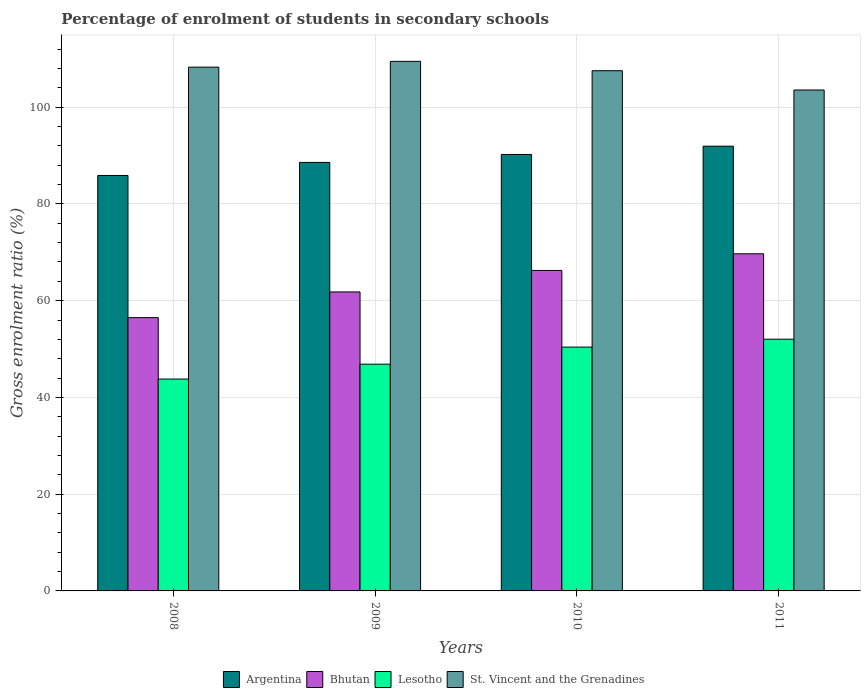How many different coloured bars are there?
Offer a terse response. 4. Are the number of bars on each tick of the X-axis equal?
Offer a very short reply. Yes. In how many cases, is the number of bars for a given year not equal to the number of legend labels?
Make the answer very short. 0. What is the percentage of students enrolled in secondary schools in Lesotho in 2011?
Provide a short and direct response. 52.04. Across all years, what is the maximum percentage of students enrolled in secondary schools in St. Vincent and the Grenadines?
Ensure brevity in your answer.  109.48. Across all years, what is the minimum percentage of students enrolled in secondary schools in Lesotho?
Ensure brevity in your answer.  43.8. What is the total percentage of students enrolled in secondary schools in Lesotho in the graph?
Keep it short and to the point. 193.11. What is the difference between the percentage of students enrolled in secondary schools in Argentina in 2010 and that in 2011?
Offer a terse response. -1.71. What is the difference between the percentage of students enrolled in secondary schools in St. Vincent and the Grenadines in 2011 and the percentage of students enrolled in secondary schools in Argentina in 2008?
Ensure brevity in your answer.  17.67. What is the average percentage of students enrolled in secondary schools in Lesotho per year?
Provide a succinct answer. 48.28. In the year 2009, what is the difference between the percentage of students enrolled in secondary schools in Bhutan and percentage of students enrolled in secondary schools in St. Vincent and the Grenadines?
Provide a short and direct response. -47.67. What is the ratio of the percentage of students enrolled in secondary schools in Bhutan in 2010 to that in 2011?
Offer a terse response. 0.95. Is the percentage of students enrolled in secondary schools in St. Vincent and the Grenadines in 2010 less than that in 2011?
Your answer should be very brief. No. What is the difference between the highest and the second highest percentage of students enrolled in secondary schools in Argentina?
Offer a terse response. 1.71. What is the difference between the highest and the lowest percentage of students enrolled in secondary schools in St. Vincent and the Grenadines?
Provide a succinct answer. 5.92. In how many years, is the percentage of students enrolled in secondary schools in Bhutan greater than the average percentage of students enrolled in secondary schools in Bhutan taken over all years?
Provide a succinct answer. 2. What does the 4th bar from the left in 2009 represents?
Provide a succinct answer. St. Vincent and the Grenadines. What does the 1st bar from the right in 2009 represents?
Provide a short and direct response. St. Vincent and the Grenadines. Are all the bars in the graph horizontal?
Keep it short and to the point. No. How many years are there in the graph?
Your answer should be very brief. 4. What is the difference between two consecutive major ticks on the Y-axis?
Ensure brevity in your answer.  20. Are the values on the major ticks of Y-axis written in scientific E-notation?
Provide a short and direct response. No. What is the title of the graph?
Your answer should be compact. Percentage of enrolment of students in secondary schools. What is the label or title of the X-axis?
Make the answer very short. Years. What is the Gross enrolment ratio (%) in Argentina in 2008?
Your answer should be compact. 85.89. What is the Gross enrolment ratio (%) of Bhutan in 2008?
Make the answer very short. 56.49. What is the Gross enrolment ratio (%) of Lesotho in 2008?
Your response must be concise. 43.8. What is the Gross enrolment ratio (%) of St. Vincent and the Grenadines in 2008?
Offer a very short reply. 108.28. What is the Gross enrolment ratio (%) of Argentina in 2009?
Make the answer very short. 88.58. What is the Gross enrolment ratio (%) of Bhutan in 2009?
Keep it short and to the point. 61.81. What is the Gross enrolment ratio (%) in Lesotho in 2009?
Give a very brief answer. 46.87. What is the Gross enrolment ratio (%) of St. Vincent and the Grenadines in 2009?
Provide a short and direct response. 109.48. What is the Gross enrolment ratio (%) of Argentina in 2010?
Your answer should be very brief. 90.23. What is the Gross enrolment ratio (%) in Bhutan in 2010?
Offer a terse response. 66.25. What is the Gross enrolment ratio (%) in Lesotho in 2010?
Give a very brief answer. 50.4. What is the Gross enrolment ratio (%) in St. Vincent and the Grenadines in 2010?
Offer a terse response. 107.54. What is the Gross enrolment ratio (%) in Argentina in 2011?
Your answer should be very brief. 91.94. What is the Gross enrolment ratio (%) in Bhutan in 2011?
Give a very brief answer. 69.69. What is the Gross enrolment ratio (%) of Lesotho in 2011?
Provide a short and direct response. 52.04. What is the Gross enrolment ratio (%) in St. Vincent and the Grenadines in 2011?
Keep it short and to the point. 103.55. Across all years, what is the maximum Gross enrolment ratio (%) of Argentina?
Provide a short and direct response. 91.94. Across all years, what is the maximum Gross enrolment ratio (%) of Bhutan?
Offer a very short reply. 69.69. Across all years, what is the maximum Gross enrolment ratio (%) in Lesotho?
Your answer should be compact. 52.04. Across all years, what is the maximum Gross enrolment ratio (%) of St. Vincent and the Grenadines?
Provide a short and direct response. 109.48. Across all years, what is the minimum Gross enrolment ratio (%) in Argentina?
Give a very brief answer. 85.89. Across all years, what is the minimum Gross enrolment ratio (%) in Bhutan?
Provide a short and direct response. 56.49. Across all years, what is the minimum Gross enrolment ratio (%) of Lesotho?
Offer a very short reply. 43.8. Across all years, what is the minimum Gross enrolment ratio (%) in St. Vincent and the Grenadines?
Provide a succinct answer. 103.55. What is the total Gross enrolment ratio (%) in Argentina in the graph?
Your response must be concise. 356.63. What is the total Gross enrolment ratio (%) of Bhutan in the graph?
Provide a short and direct response. 254.25. What is the total Gross enrolment ratio (%) of Lesotho in the graph?
Make the answer very short. 193.11. What is the total Gross enrolment ratio (%) of St. Vincent and the Grenadines in the graph?
Offer a very short reply. 428.85. What is the difference between the Gross enrolment ratio (%) of Argentina in 2008 and that in 2009?
Keep it short and to the point. -2.69. What is the difference between the Gross enrolment ratio (%) in Bhutan in 2008 and that in 2009?
Offer a very short reply. -5.31. What is the difference between the Gross enrolment ratio (%) of Lesotho in 2008 and that in 2009?
Make the answer very short. -3.07. What is the difference between the Gross enrolment ratio (%) in St. Vincent and the Grenadines in 2008 and that in 2009?
Provide a short and direct response. -1.2. What is the difference between the Gross enrolment ratio (%) in Argentina in 2008 and that in 2010?
Your answer should be very brief. -4.34. What is the difference between the Gross enrolment ratio (%) in Bhutan in 2008 and that in 2010?
Keep it short and to the point. -9.76. What is the difference between the Gross enrolment ratio (%) in Lesotho in 2008 and that in 2010?
Make the answer very short. -6.61. What is the difference between the Gross enrolment ratio (%) of St. Vincent and the Grenadines in 2008 and that in 2010?
Ensure brevity in your answer.  0.74. What is the difference between the Gross enrolment ratio (%) of Argentina in 2008 and that in 2011?
Make the answer very short. -6.05. What is the difference between the Gross enrolment ratio (%) in Bhutan in 2008 and that in 2011?
Offer a very short reply. -13.2. What is the difference between the Gross enrolment ratio (%) of Lesotho in 2008 and that in 2011?
Give a very brief answer. -8.24. What is the difference between the Gross enrolment ratio (%) of St. Vincent and the Grenadines in 2008 and that in 2011?
Keep it short and to the point. 4.72. What is the difference between the Gross enrolment ratio (%) in Argentina in 2009 and that in 2010?
Give a very brief answer. -1.65. What is the difference between the Gross enrolment ratio (%) in Bhutan in 2009 and that in 2010?
Keep it short and to the point. -4.45. What is the difference between the Gross enrolment ratio (%) in Lesotho in 2009 and that in 2010?
Provide a succinct answer. -3.53. What is the difference between the Gross enrolment ratio (%) in St. Vincent and the Grenadines in 2009 and that in 2010?
Provide a succinct answer. 1.94. What is the difference between the Gross enrolment ratio (%) of Argentina in 2009 and that in 2011?
Your answer should be compact. -3.36. What is the difference between the Gross enrolment ratio (%) in Bhutan in 2009 and that in 2011?
Offer a very short reply. -7.89. What is the difference between the Gross enrolment ratio (%) in Lesotho in 2009 and that in 2011?
Your answer should be compact. -5.16. What is the difference between the Gross enrolment ratio (%) in St. Vincent and the Grenadines in 2009 and that in 2011?
Provide a succinct answer. 5.92. What is the difference between the Gross enrolment ratio (%) in Argentina in 2010 and that in 2011?
Your answer should be compact. -1.71. What is the difference between the Gross enrolment ratio (%) in Bhutan in 2010 and that in 2011?
Provide a succinct answer. -3.44. What is the difference between the Gross enrolment ratio (%) in Lesotho in 2010 and that in 2011?
Your response must be concise. -1.63. What is the difference between the Gross enrolment ratio (%) of St. Vincent and the Grenadines in 2010 and that in 2011?
Offer a terse response. 3.98. What is the difference between the Gross enrolment ratio (%) of Argentina in 2008 and the Gross enrolment ratio (%) of Bhutan in 2009?
Make the answer very short. 24.08. What is the difference between the Gross enrolment ratio (%) in Argentina in 2008 and the Gross enrolment ratio (%) in Lesotho in 2009?
Ensure brevity in your answer.  39.01. What is the difference between the Gross enrolment ratio (%) in Argentina in 2008 and the Gross enrolment ratio (%) in St. Vincent and the Grenadines in 2009?
Ensure brevity in your answer.  -23.59. What is the difference between the Gross enrolment ratio (%) of Bhutan in 2008 and the Gross enrolment ratio (%) of Lesotho in 2009?
Your response must be concise. 9.62. What is the difference between the Gross enrolment ratio (%) of Bhutan in 2008 and the Gross enrolment ratio (%) of St. Vincent and the Grenadines in 2009?
Make the answer very short. -52.98. What is the difference between the Gross enrolment ratio (%) of Lesotho in 2008 and the Gross enrolment ratio (%) of St. Vincent and the Grenadines in 2009?
Provide a short and direct response. -65.68. What is the difference between the Gross enrolment ratio (%) of Argentina in 2008 and the Gross enrolment ratio (%) of Bhutan in 2010?
Your answer should be compact. 19.63. What is the difference between the Gross enrolment ratio (%) in Argentina in 2008 and the Gross enrolment ratio (%) in Lesotho in 2010?
Offer a very short reply. 35.48. What is the difference between the Gross enrolment ratio (%) in Argentina in 2008 and the Gross enrolment ratio (%) in St. Vincent and the Grenadines in 2010?
Offer a very short reply. -21.65. What is the difference between the Gross enrolment ratio (%) in Bhutan in 2008 and the Gross enrolment ratio (%) in Lesotho in 2010?
Make the answer very short. 6.09. What is the difference between the Gross enrolment ratio (%) in Bhutan in 2008 and the Gross enrolment ratio (%) in St. Vincent and the Grenadines in 2010?
Give a very brief answer. -51.04. What is the difference between the Gross enrolment ratio (%) of Lesotho in 2008 and the Gross enrolment ratio (%) of St. Vincent and the Grenadines in 2010?
Your response must be concise. -63.74. What is the difference between the Gross enrolment ratio (%) of Argentina in 2008 and the Gross enrolment ratio (%) of Bhutan in 2011?
Make the answer very short. 16.19. What is the difference between the Gross enrolment ratio (%) in Argentina in 2008 and the Gross enrolment ratio (%) in Lesotho in 2011?
Offer a very short reply. 33.85. What is the difference between the Gross enrolment ratio (%) in Argentina in 2008 and the Gross enrolment ratio (%) in St. Vincent and the Grenadines in 2011?
Offer a terse response. -17.67. What is the difference between the Gross enrolment ratio (%) of Bhutan in 2008 and the Gross enrolment ratio (%) of Lesotho in 2011?
Make the answer very short. 4.46. What is the difference between the Gross enrolment ratio (%) of Bhutan in 2008 and the Gross enrolment ratio (%) of St. Vincent and the Grenadines in 2011?
Make the answer very short. -47.06. What is the difference between the Gross enrolment ratio (%) in Lesotho in 2008 and the Gross enrolment ratio (%) in St. Vincent and the Grenadines in 2011?
Keep it short and to the point. -59.75. What is the difference between the Gross enrolment ratio (%) in Argentina in 2009 and the Gross enrolment ratio (%) in Bhutan in 2010?
Your answer should be compact. 22.33. What is the difference between the Gross enrolment ratio (%) in Argentina in 2009 and the Gross enrolment ratio (%) in Lesotho in 2010?
Your response must be concise. 38.17. What is the difference between the Gross enrolment ratio (%) of Argentina in 2009 and the Gross enrolment ratio (%) of St. Vincent and the Grenadines in 2010?
Your answer should be very brief. -18.96. What is the difference between the Gross enrolment ratio (%) in Bhutan in 2009 and the Gross enrolment ratio (%) in Lesotho in 2010?
Your answer should be very brief. 11.4. What is the difference between the Gross enrolment ratio (%) of Bhutan in 2009 and the Gross enrolment ratio (%) of St. Vincent and the Grenadines in 2010?
Provide a short and direct response. -45.73. What is the difference between the Gross enrolment ratio (%) in Lesotho in 2009 and the Gross enrolment ratio (%) in St. Vincent and the Grenadines in 2010?
Your answer should be very brief. -60.67. What is the difference between the Gross enrolment ratio (%) of Argentina in 2009 and the Gross enrolment ratio (%) of Bhutan in 2011?
Make the answer very short. 18.89. What is the difference between the Gross enrolment ratio (%) of Argentina in 2009 and the Gross enrolment ratio (%) of Lesotho in 2011?
Your answer should be compact. 36.54. What is the difference between the Gross enrolment ratio (%) of Argentina in 2009 and the Gross enrolment ratio (%) of St. Vincent and the Grenadines in 2011?
Give a very brief answer. -14.97. What is the difference between the Gross enrolment ratio (%) of Bhutan in 2009 and the Gross enrolment ratio (%) of Lesotho in 2011?
Offer a terse response. 9.77. What is the difference between the Gross enrolment ratio (%) in Bhutan in 2009 and the Gross enrolment ratio (%) in St. Vincent and the Grenadines in 2011?
Offer a terse response. -41.75. What is the difference between the Gross enrolment ratio (%) in Lesotho in 2009 and the Gross enrolment ratio (%) in St. Vincent and the Grenadines in 2011?
Provide a short and direct response. -56.68. What is the difference between the Gross enrolment ratio (%) of Argentina in 2010 and the Gross enrolment ratio (%) of Bhutan in 2011?
Make the answer very short. 20.53. What is the difference between the Gross enrolment ratio (%) in Argentina in 2010 and the Gross enrolment ratio (%) in Lesotho in 2011?
Offer a terse response. 38.19. What is the difference between the Gross enrolment ratio (%) in Argentina in 2010 and the Gross enrolment ratio (%) in St. Vincent and the Grenadines in 2011?
Provide a short and direct response. -13.33. What is the difference between the Gross enrolment ratio (%) in Bhutan in 2010 and the Gross enrolment ratio (%) in Lesotho in 2011?
Make the answer very short. 14.22. What is the difference between the Gross enrolment ratio (%) of Bhutan in 2010 and the Gross enrolment ratio (%) of St. Vincent and the Grenadines in 2011?
Make the answer very short. -37.3. What is the difference between the Gross enrolment ratio (%) of Lesotho in 2010 and the Gross enrolment ratio (%) of St. Vincent and the Grenadines in 2011?
Your answer should be very brief. -53.15. What is the average Gross enrolment ratio (%) of Argentina per year?
Keep it short and to the point. 89.16. What is the average Gross enrolment ratio (%) in Bhutan per year?
Offer a very short reply. 63.56. What is the average Gross enrolment ratio (%) in Lesotho per year?
Your answer should be compact. 48.28. What is the average Gross enrolment ratio (%) in St. Vincent and the Grenadines per year?
Your response must be concise. 107.21. In the year 2008, what is the difference between the Gross enrolment ratio (%) in Argentina and Gross enrolment ratio (%) in Bhutan?
Ensure brevity in your answer.  29.39. In the year 2008, what is the difference between the Gross enrolment ratio (%) in Argentina and Gross enrolment ratio (%) in Lesotho?
Ensure brevity in your answer.  42.09. In the year 2008, what is the difference between the Gross enrolment ratio (%) in Argentina and Gross enrolment ratio (%) in St. Vincent and the Grenadines?
Provide a short and direct response. -22.39. In the year 2008, what is the difference between the Gross enrolment ratio (%) in Bhutan and Gross enrolment ratio (%) in Lesotho?
Give a very brief answer. 12.7. In the year 2008, what is the difference between the Gross enrolment ratio (%) of Bhutan and Gross enrolment ratio (%) of St. Vincent and the Grenadines?
Your answer should be very brief. -51.78. In the year 2008, what is the difference between the Gross enrolment ratio (%) of Lesotho and Gross enrolment ratio (%) of St. Vincent and the Grenadines?
Your answer should be very brief. -64.48. In the year 2009, what is the difference between the Gross enrolment ratio (%) of Argentina and Gross enrolment ratio (%) of Bhutan?
Ensure brevity in your answer.  26.77. In the year 2009, what is the difference between the Gross enrolment ratio (%) of Argentina and Gross enrolment ratio (%) of Lesotho?
Provide a succinct answer. 41.71. In the year 2009, what is the difference between the Gross enrolment ratio (%) of Argentina and Gross enrolment ratio (%) of St. Vincent and the Grenadines?
Ensure brevity in your answer.  -20.9. In the year 2009, what is the difference between the Gross enrolment ratio (%) of Bhutan and Gross enrolment ratio (%) of Lesotho?
Make the answer very short. 14.93. In the year 2009, what is the difference between the Gross enrolment ratio (%) in Bhutan and Gross enrolment ratio (%) in St. Vincent and the Grenadines?
Offer a terse response. -47.67. In the year 2009, what is the difference between the Gross enrolment ratio (%) of Lesotho and Gross enrolment ratio (%) of St. Vincent and the Grenadines?
Offer a very short reply. -62.6. In the year 2010, what is the difference between the Gross enrolment ratio (%) of Argentina and Gross enrolment ratio (%) of Bhutan?
Your response must be concise. 23.97. In the year 2010, what is the difference between the Gross enrolment ratio (%) in Argentina and Gross enrolment ratio (%) in Lesotho?
Your answer should be compact. 39.82. In the year 2010, what is the difference between the Gross enrolment ratio (%) in Argentina and Gross enrolment ratio (%) in St. Vincent and the Grenadines?
Offer a very short reply. -17.31. In the year 2010, what is the difference between the Gross enrolment ratio (%) of Bhutan and Gross enrolment ratio (%) of Lesotho?
Keep it short and to the point. 15.85. In the year 2010, what is the difference between the Gross enrolment ratio (%) of Bhutan and Gross enrolment ratio (%) of St. Vincent and the Grenadines?
Give a very brief answer. -41.29. In the year 2010, what is the difference between the Gross enrolment ratio (%) of Lesotho and Gross enrolment ratio (%) of St. Vincent and the Grenadines?
Your response must be concise. -57.13. In the year 2011, what is the difference between the Gross enrolment ratio (%) of Argentina and Gross enrolment ratio (%) of Bhutan?
Your response must be concise. 22.24. In the year 2011, what is the difference between the Gross enrolment ratio (%) in Argentina and Gross enrolment ratio (%) in Lesotho?
Make the answer very short. 39.9. In the year 2011, what is the difference between the Gross enrolment ratio (%) in Argentina and Gross enrolment ratio (%) in St. Vincent and the Grenadines?
Offer a terse response. -11.62. In the year 2011, what is the difference between the Gross enrolment ratio (%) of Bhutan and Gross enrolment ratio (%) of Lesotho?
Provide a short and direct response. 17.66. In the year 2011, what is the difference between the Gross enrolment ratio (%) of Bhutan and Gross enrolment ratio (%) of St. Vincent and the Grenadines?
Make the answer very short. -33.86. In the year 2011, what is the difference between the Gross enrolment ratio (%) in Lesotho and Gross enrolment ratio (%) in St. Vincent and the Grenadines?
Keep it short and to the point. -51.52. What is the ratio of the Gross enrolment ratio (%) of Argentina in 2008 to that in 2009?
Provide a short and direct response. 0.97. What is the ratio of the Gross enrolment ratio (%) of Bhutan in 2008 to that in 2009?
Your response must be concise. 0.91. What is the ratio of the Gross enrolment ratio (%) of Lesotho in 2008 to that in 2009?
Your response must be concise. 0.93. What is the ratio of the Gross enrolment ratio (%) in St. Vincent and the Grenadines in 2008 to that in 2009?
Make the answer very short. 0.99. What is the ratio of the Gross enrolment ratio (%) of Argentina in 2008 to that in 2010?
Provide a succinct answer. 0.95. What is the ratio of the Gross enrolment ratio (%) in Bhutan in 2008 to that in 2010?
Make the answer very short. 0.85. What is the ratio of the Gross enrolment ratio (%) of Lesotho in 2008 to that in 2010?
Give a very brief answer. 0.87. What is the ratio of the Gross enrolment ratio (%) of St. Vincent and the Grenadines in 2008 to that in 2010?
Offer a terse response. 1.01. What is the ratio of the Gross enrolment ratio (%) in Argentina in 2008 to that in 2011?
Your answer should be compact. 0.93. What is the ratio of the Gross enrolment ratio (%) in Bhutan in 2008 to that in 2011?
Provide a short and direct response. 0.81. What is the ratio of the Gross enrolment ratio (%) in Lesotho in 2008 to that in 2011?
Offer a terse response. 0.84. What is the ratio of the Gross enrolment ratio (%) of St. Vincent and the Grenadines in 2008 to that in 2011?
Give a very brief answer. 1.05. What is the ratio of the Gross enrolment ratio (%) of Argentina in 2009 to that in 2010?
Provide a succinct answer. 0.98. What is the ratio of the Gross enrolment ratio (%) in Bhutan in 2009 to that in 2010?
Offer a very short reply. 0.93. What is the ratio of the Gross enrolment ratio (%) in Lesotho in 2009 to that in 2010?
Provide a succinct answer. 0.93. What is the ratio of the Gross enrolment ratio (%) of St. Vincent and the Grenadines in 2009 to that in 2010?
Provide a succinct answer. 1.02. What is the ratio of the Gross enrolment ratio (%) in Argentina in 2009 to that in 2011?
Provide a short and direct response. 0.96. What is the ratio of the Gross enrolment ratio (%) in Bhutan in 2009 to that in 2011?
Your answer should be very brief. 0.89. What is the ratio of the Gross enrolment ratio (%) in Lesotho in 2009 to that in 2011?
Give a very brief answer. 0.9. What is the ratio of the Gross enrolment ratio (%) of St. Vincent and the Grenadines in 2009 to that in 2011?
Make the answer very short. 1.06. What is the ratio of the Gross enrolment ratio (%) of Argentina in 2010 to that in 2011?
Your answer should be compact. 0.98. What is the ratio of the Gross enrolment ratio (%) in Bhutan in 2010 to that in 2011?
Provide a succinct answer. 0.95. What is the ratio of the Gross enrolment ratio (%) in Lesotho in 2010 to that in 2011?
Ensure brevity in your answer.  0.97. What is the ratio of the Gross enrolment ratio (%) in St. Vincent and the Grenadines in 2010 to that in 2011?
Give a very brief answer. 1.04. What is the difference between the highest and the second highest Gross enrolment ratio (%) in Argentina?
Your response must be concise. 1.71. What is the difference between the highest and the second highest Gross enrolment ratio (%) of Bhutan?
Your response must be concise. 3.44. What is the difference between the highest and the second highest Gross enrolment ratio (%) of Lesotho?
Your response must be concise. 1.63. What is the difference between the highest and the second highest Gross enrolment ratio (%) in St. Vincent and the Grenadines?
Keep it short and to the point. 1.2. What is the difference between the highest and the lowest Gross enrolment ratio (%) in Argentina?
Your answer should be very brief. 6.05. What is the difference between the highest and the lowest Gross enrolment ratio (%) of Bhutan?
Your answer should be compact. 13.2. What is the difference between the highest and the lowest Gross enrolment ratio (%) of Lesotho?
Offer a terse response. 8.24. What is the difference between the highest and the lowest Gross enrolment ratio (%) of St. Vincent and the Grenadines?
Ensure brevity in your answer.  5.92. 